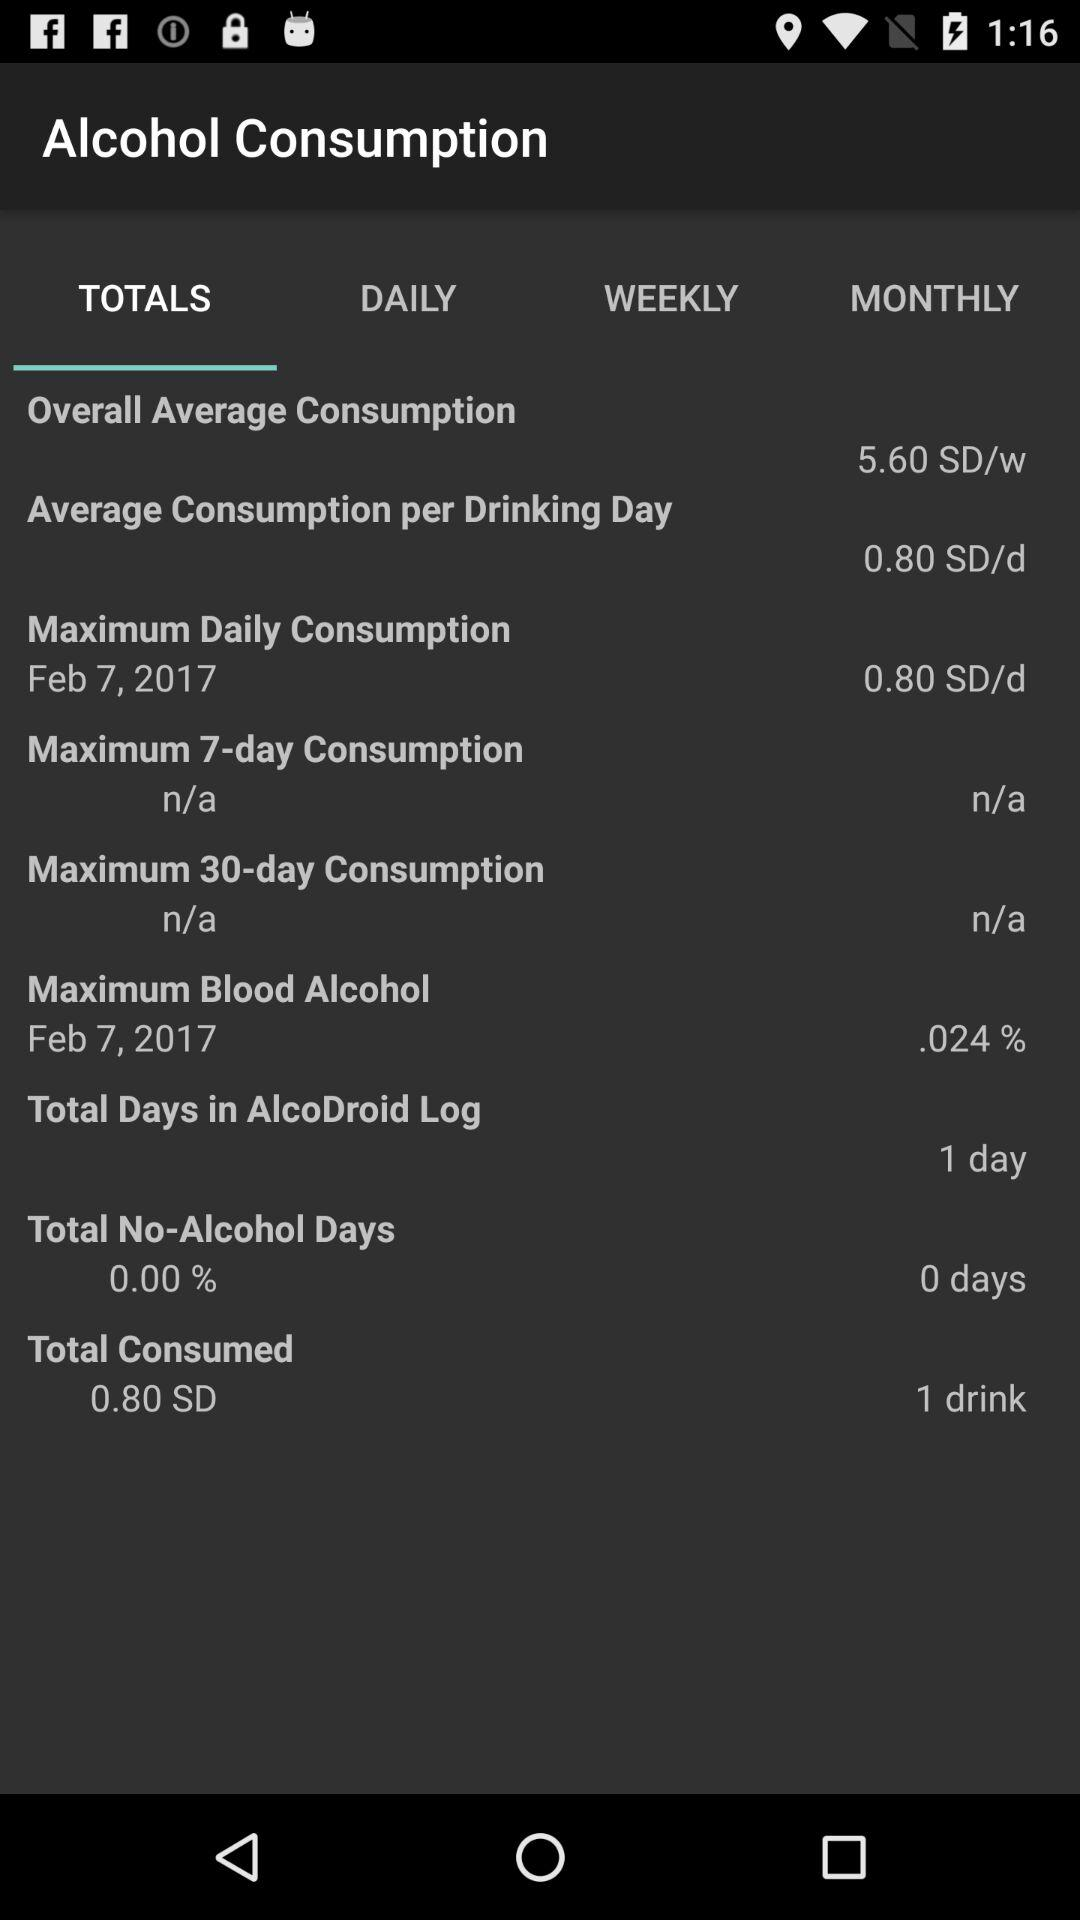What is the maximum daily consumption? The maximum daily consumption is 0.80 SD/d. 